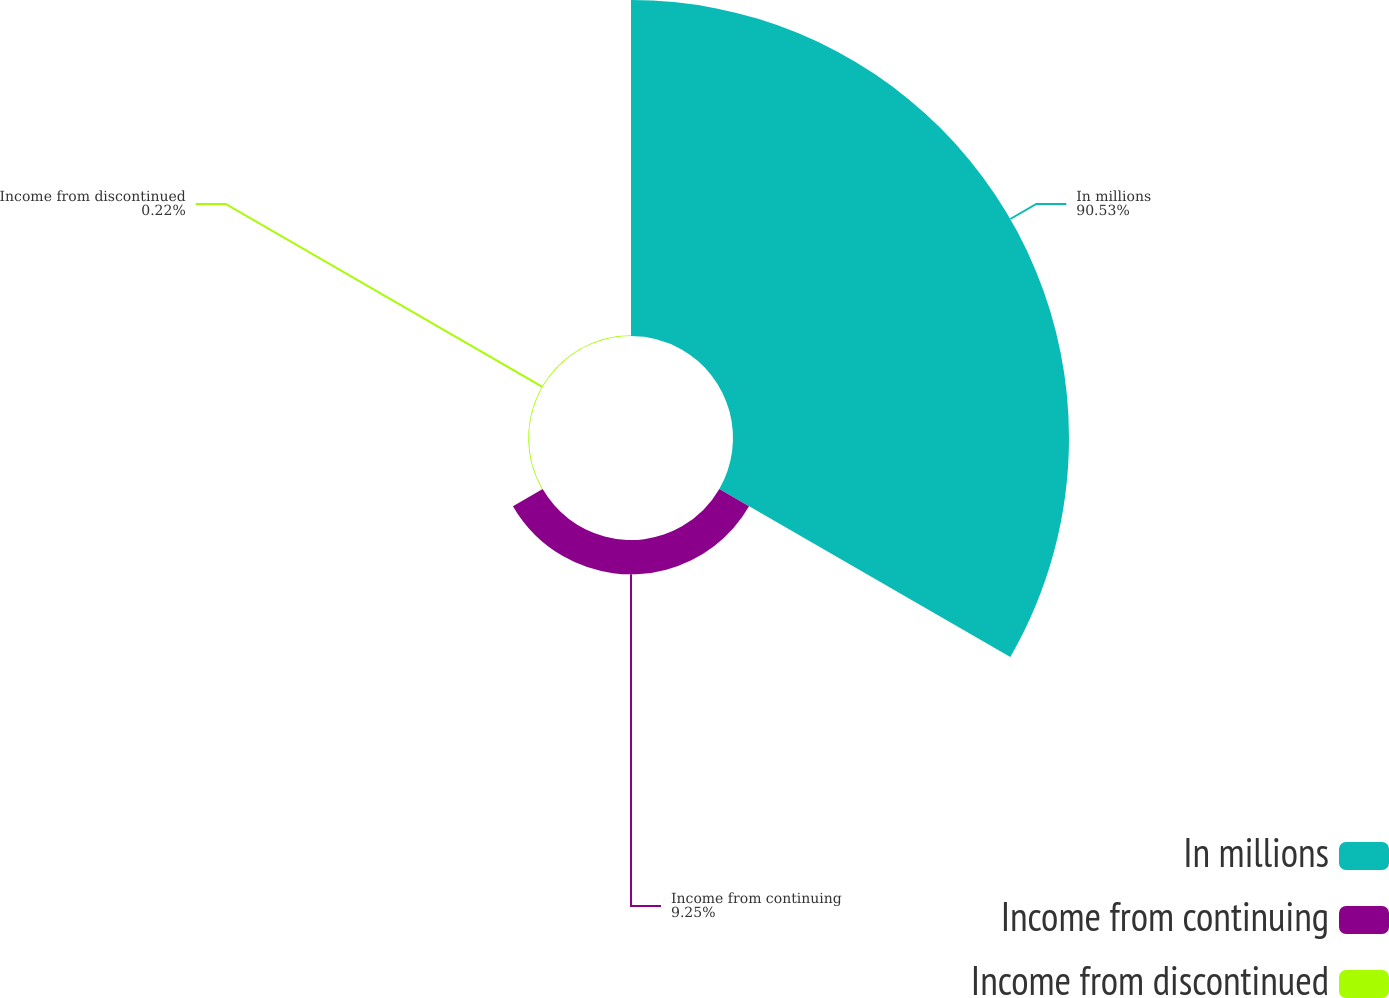<chart> <loc_0><loc_0><loc_500><loc_500><pie_chart><fcel>In millions<fcel>Income from continuing<fcel>Income from discontinued<nl><fcel>90.52%<fcel>9.25%<fcel>0.22%<nl></chart> 